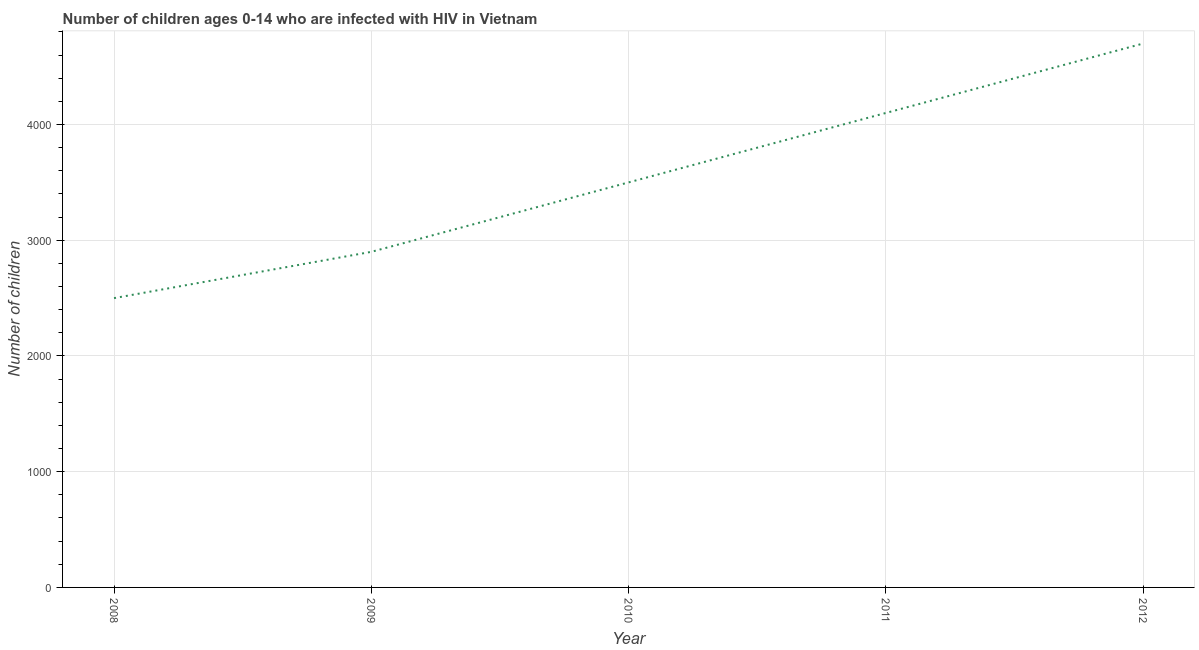What is the number of children living with hiv in 2011?
Offer a terse response. 4100. Across all years, what is the maximum number of children living with hiv?
Make the answer very short. 4700. Across all years, what is the minimum number of children living with hiv?
Offer a very short reply. 2500. In which year was the number of children living with hiv maximum?
Provide a succinct answer. 2012. In which year was the number of children living with hiv minimum?
Offer a very short reply. 2008. What is the sum of the number of children living with hiv?
Ensure brevity in your answer.  1.77e+04. What is the difference between the number of children living with hiv in 2008 and 2010?
Make the answer very short. -1000. What is the average number of children living with hiv per year?
Offer a terse response. 3540. What is the median number of children living with hiv?
Ensure brevity in your answer.  3500. In how many years, is the number of children living with hiv greater than 800 ?
Your answer should be compact. 5. What is the ratio of the number of children living with hiv in 2008 to that in 2009?
Make the answer very short. 0.86. Is the number of children living with hiv in 2009 less than that in 2011?
Ensure brevity in your answer.  Yes. What is the difference between the highest and the second highest number of children living with hiv?
Give a very brief answer. 600. What is the difference between the highest and the lowest number of children living with hiv?
Offer a terse response. 2200. In how many years, is the number of children living with hiv greater than the average number of children living with hiv taken over all years?
Your answer should be very brief. 2. Does the number of children living with hiv monotonically increase over the years?
Keep it short and to the point. Yes. How many years are there in the graph?
Provide a short and direct response. 5. Are the values on the major ticks of Y-axis written in scientific E-notation?
Make the answer very short. No. Does the graph contain any zero values?
Provide a succinct answer. No. What is the title of the graph?
Ensure brevity in your answer.  Number of children ages 0-14 who are infected with HIV in Vietnam. What is the label or title of the X-axis?
Keep it short and to the point. Year. What is the label or title of the Y-axis?
Keep it short and to the point. Number of children. What is the Number of children in 2008?
Provide a short and direct response. 2500. What is the Number of children of 2009?
Provide a succinct answer. 2900. What is the Number of children of 2010?
Ensure brevity in your answer.  3500. What is the Number of children of 2011?
Provide a short and direct response. 4100. What is the Number of children in 2012?
Ensure brevity in your answer.  4700. What is the difference between the Number of children in 2008 and 2009?
Offer a very short reply. -400. What is the difference between the Number of children in 2008 and 2010?
Offer a terse response. -1000. What is the difference between the Number of children in 2008 and 2011?
Offer a terse response. -1600. What is the difference between the Number of children in 2008 and 2012?
Keep it short and to the point. -2200. What is the difference between the Number of children in 2009 and 2010?
Your answer should be compact. -600. What is the difference between the Number of children in 2009 and 2011?
Make the answer very short. -1200. What is the difference between the Number of children in 2009 and 2012?
Give a very brief answer. -1800. What is the difference between the Number of children in 2010 and 2011?
Offer a terse response. -600. What is the difference between the Number of children in 2010 and 2012?
Provide a succinct answer. -1200. What is the difference between the Number of children in 2011 and 2012?
Ensure brevity in your answer.  -600. What is the ratio of the Number of children in 2008 to that in 2009?
Your response must be concise. 0.86. What is the ratio of the Number of children in 2008 to that in 2010?
Your response must be concise. 0.71. What is the ratio of the Number of children in 2008 to that in 2011?
Your response must be concise. 0.61. What is the ratio of the Number of children in 2008 to that in 2012?
Provide a short and direct response. 0.53. What is the ratio of the Number of children in 2009 to that in 2010?
Provide a short and direct response. 0.83. What is the ratio of the Number of children in 2009 to that in 2011?
Keep it short and to the point. 0.71. What is the ratio of the Number of children in 2009 to that in 2012?
Your answer should be very brief. 0.62. What is the ratio of the Number of children in 2010 to that in 2011?
Your answer should be very brief. 0.85. What is the ratio of the Number of children in 2010 to that in 2012?
Your response must be concise. 0.74. What is the ratio of the Number of children in 2011 to that in 2012?
Offer a terse response. 0.87. 